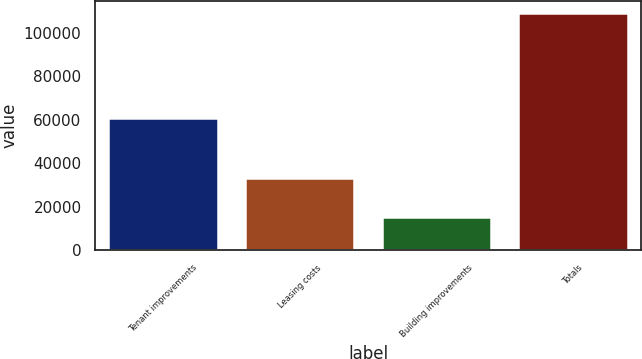<chart> <loc_0><loc_0><loc_500><loc_500><bar_chart><fcel>Tenant improvements<fcel>Leasing costs<fcel>Building improvements<fcel>Totals<nl><fcel>60633<fcel>33175<fcel>15232<fcel>109040<nl></chart> 